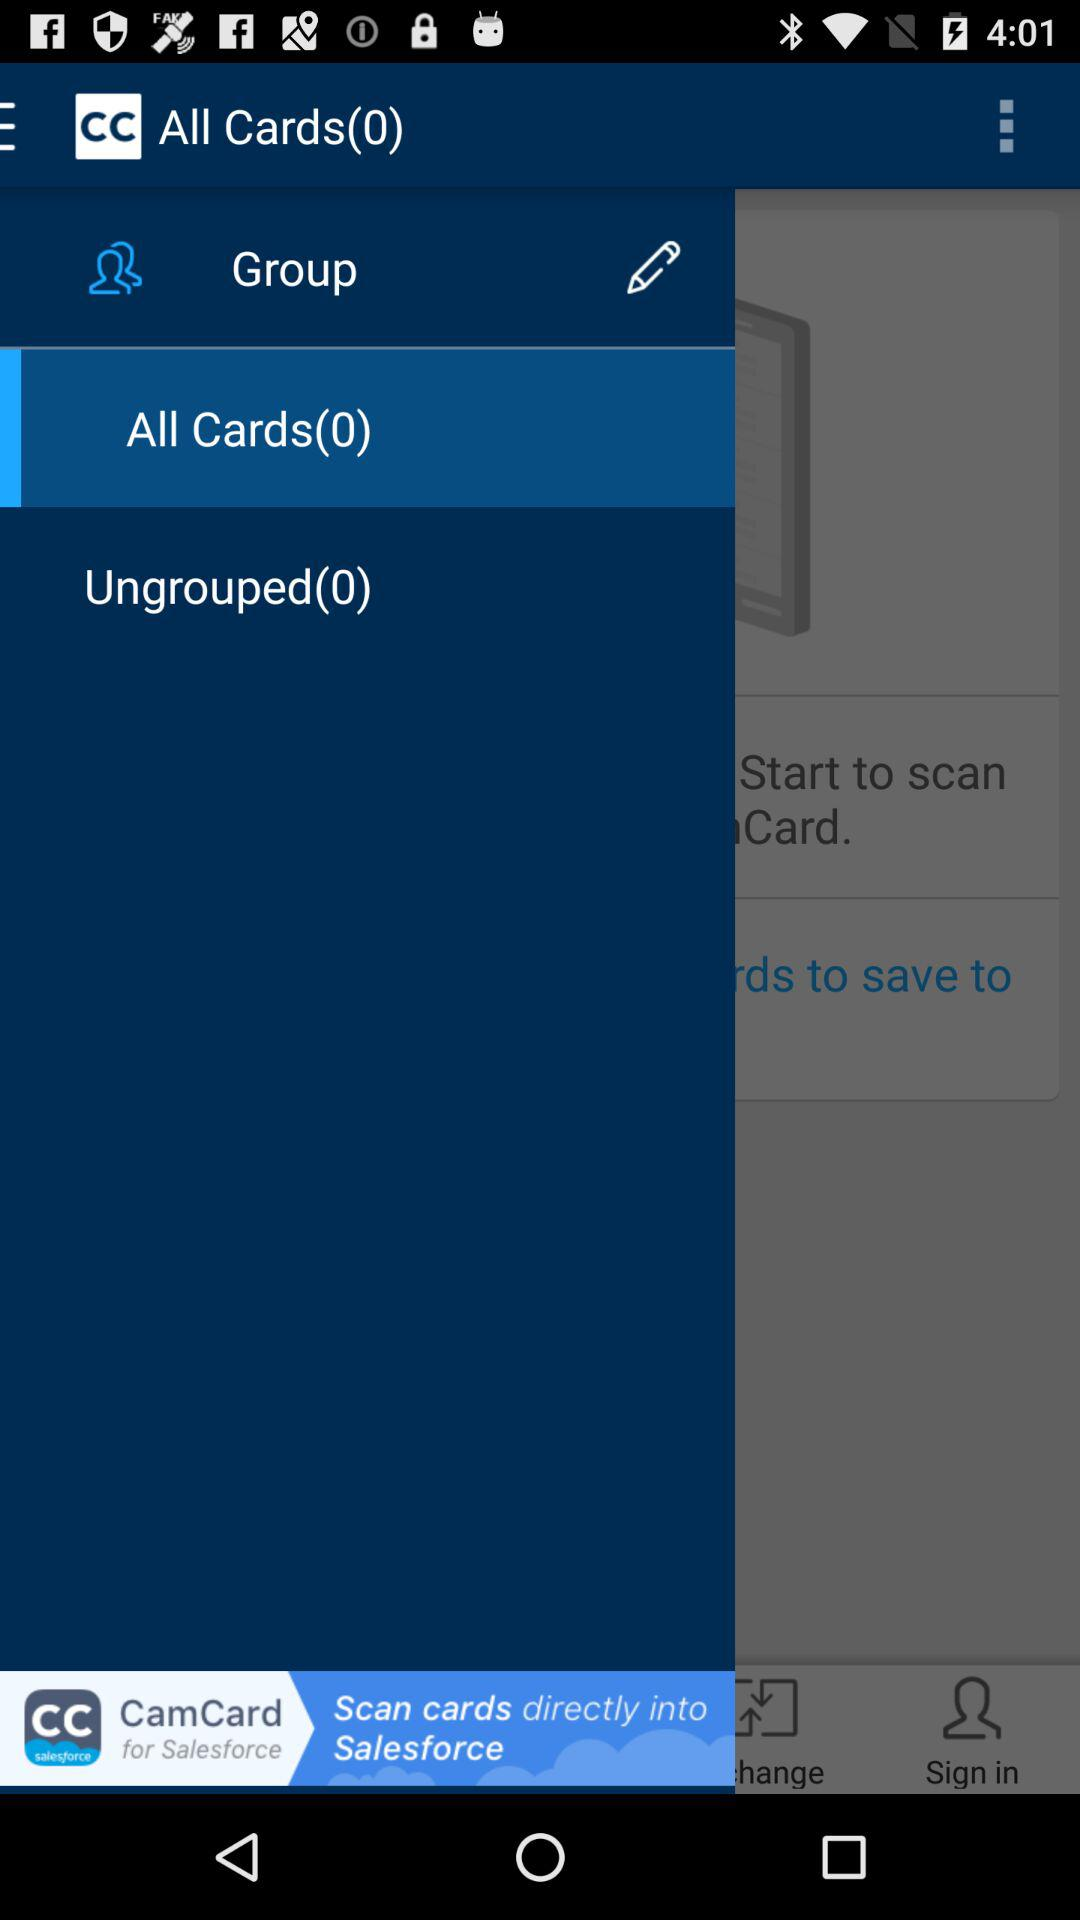What is the selected item? The selected item is "All Cards(0)". 